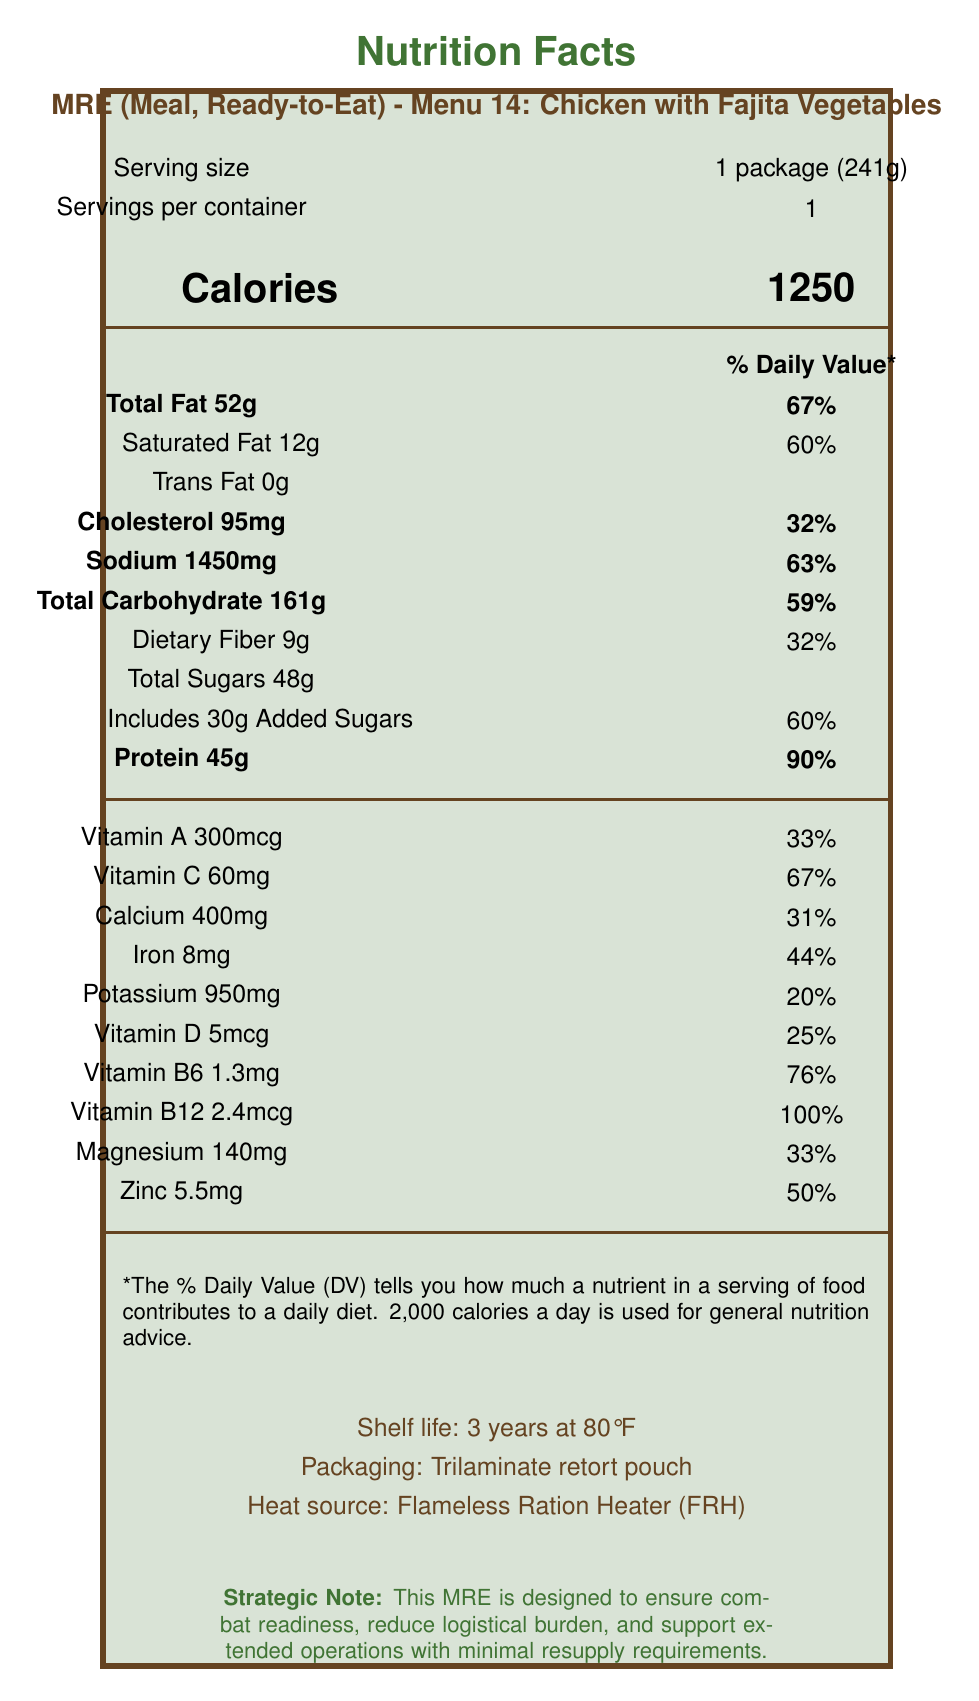what is the serving size for this MRE? The serving size is explicitly stated as "1 package (241g)" in the document.
Answer: 1 package (241g) how many calories are in one serving? The number of calories per serving is listed as 1250.
Answer: 1250 how much protein does this MRE contain? The protein content is stated as 45g.
Answer: 45g how many grams of dietary fiber does this MRE include? The amount of dietary fiber is listed as 9g.
Answer: 9g what percentage of the daily value for sodium does this MRE provide? The document states that the sodium content is 1450mg, which corresponds to 63% of the daily value.
Answer: 63% which of the following vitamins has the highest Daily Value percentage in this MRE? A. Vitamin A B. Vitamin B6 C. Vitamin B12 D. Vitamin C The Daily Value percentage for Vitamin B12 is 100%, which is higher than Vitamin A (33%), Vitamin B6 (76%), and Vitamin C (67%).
Answer: C. Vitamin B12 how long is the shelf life of this MRE? The document explicitly states the shelf life as "3 years at 80°F."
Answer: 3 years at 80°F does this MRE contain any trans fat? The document indicates that the trans fat content is 0g.
Answer: No what is the total amount of carbohydrates in this MRE? A. 59g B. 95g C. 161g D. 180g The total amount of carbohydrates is listed as 161g.
Answer: C. 161g does this MRE include any meal accessories? The additional information section lists several accessories, including a plastic spoon, napkin, moist towelette, matches, and chewing gum.
Answer: Yes summarize the main purpose of this MRE. The summary covers the high calorie content, balanced nutrition, logistical benefits, and durability, highlighting the purpose and strategic importance of the MRE.
Answer: The MRE is designed for military use, providing high calorie, balanced meals with essential nutrients to maintain combat readiness, reduce logistical burden, and support extended operations. It is durable and can withstand extreme conditions. how is the MRE heated? The document states that the heat source for the MRE is a Flameless Ration Heater (FRH).
Answer: Flameless Ration Heater (FRH) what is the exact amount of magnesium in this MRE? The magnesium content is stated as 140mg.
Answer: 140mg what are the side dishes included in this MRE? The document lists the side dishes as Mexican style rice and refried beans.
Answer: Mexican style rice, Refried beans what flavor is the energy bar included in this MRE? The energy bar is described as "First Strike energy bar (Chocolate)."
Answer: Chocolate is the packaging of this MRE eco-friendly? The document does not provide information regarding the eco-friendliness of the packaging.
Answer: Cannot be determined 